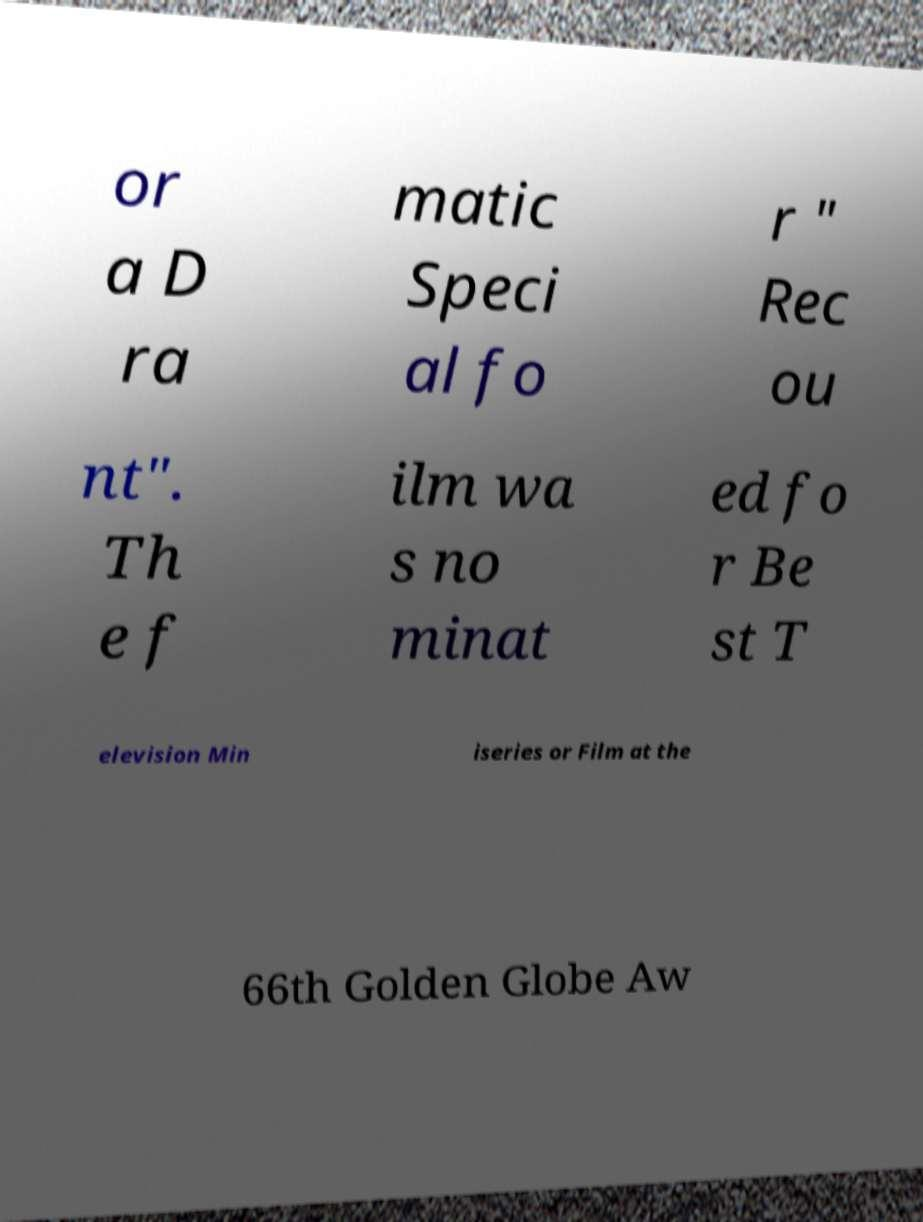What messages or text are displayed in this image? I need them in a readable, typed format. or a D ra matic Speci al fo r " Rec ou nt". Th e f ilm wa s no minat ed fo r Be st T elevision Min iseries or Film at the 66th Golden Globe Aw 